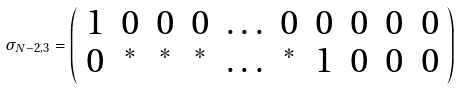<formula> <loc_0><loc_0><loc_500><loc_500>\sigma _ { N - 2 , 3 } = \left ( \begin{array} { c c c c c c c c c c } { 1 } & { 0 } & { 0 } & { 0 } & { \dots } & { 0 } & { 0 } & { 0 } & { 0 } & { 0 } \\ { 0 } & { ^ { * } } & { ^ { * } } & { ^ { * } } & { \dots } & { ^ { * } } & { 1 } & { 0 } & { 0 } & { 0 } \end{array} \right )</formula> 